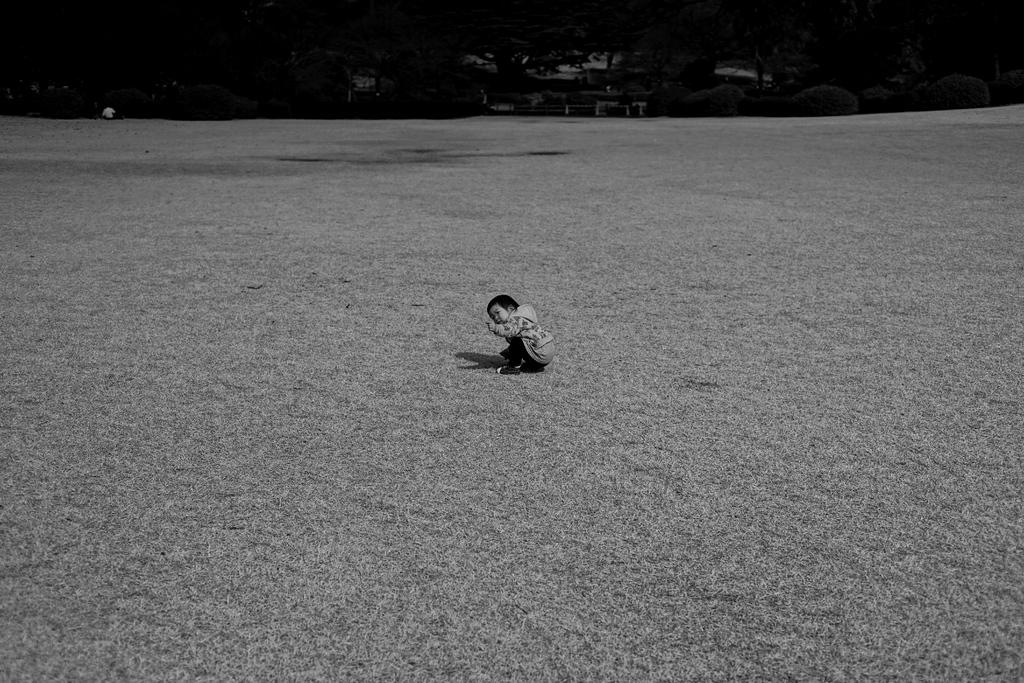What is the color scheme of the image? The image is black and white. What is the boy doing in the image? The boy is sitting on the grassy land. What can be seen in the background of the image? There are plants and trees in the background. What type of pie is the boy holding in the image? There is no pie present in the image; the boy is sitting on the grassy land. What is the boy's purpose for being in the image? The image does not provide information about the boy's purpose or reason for being in the image. 